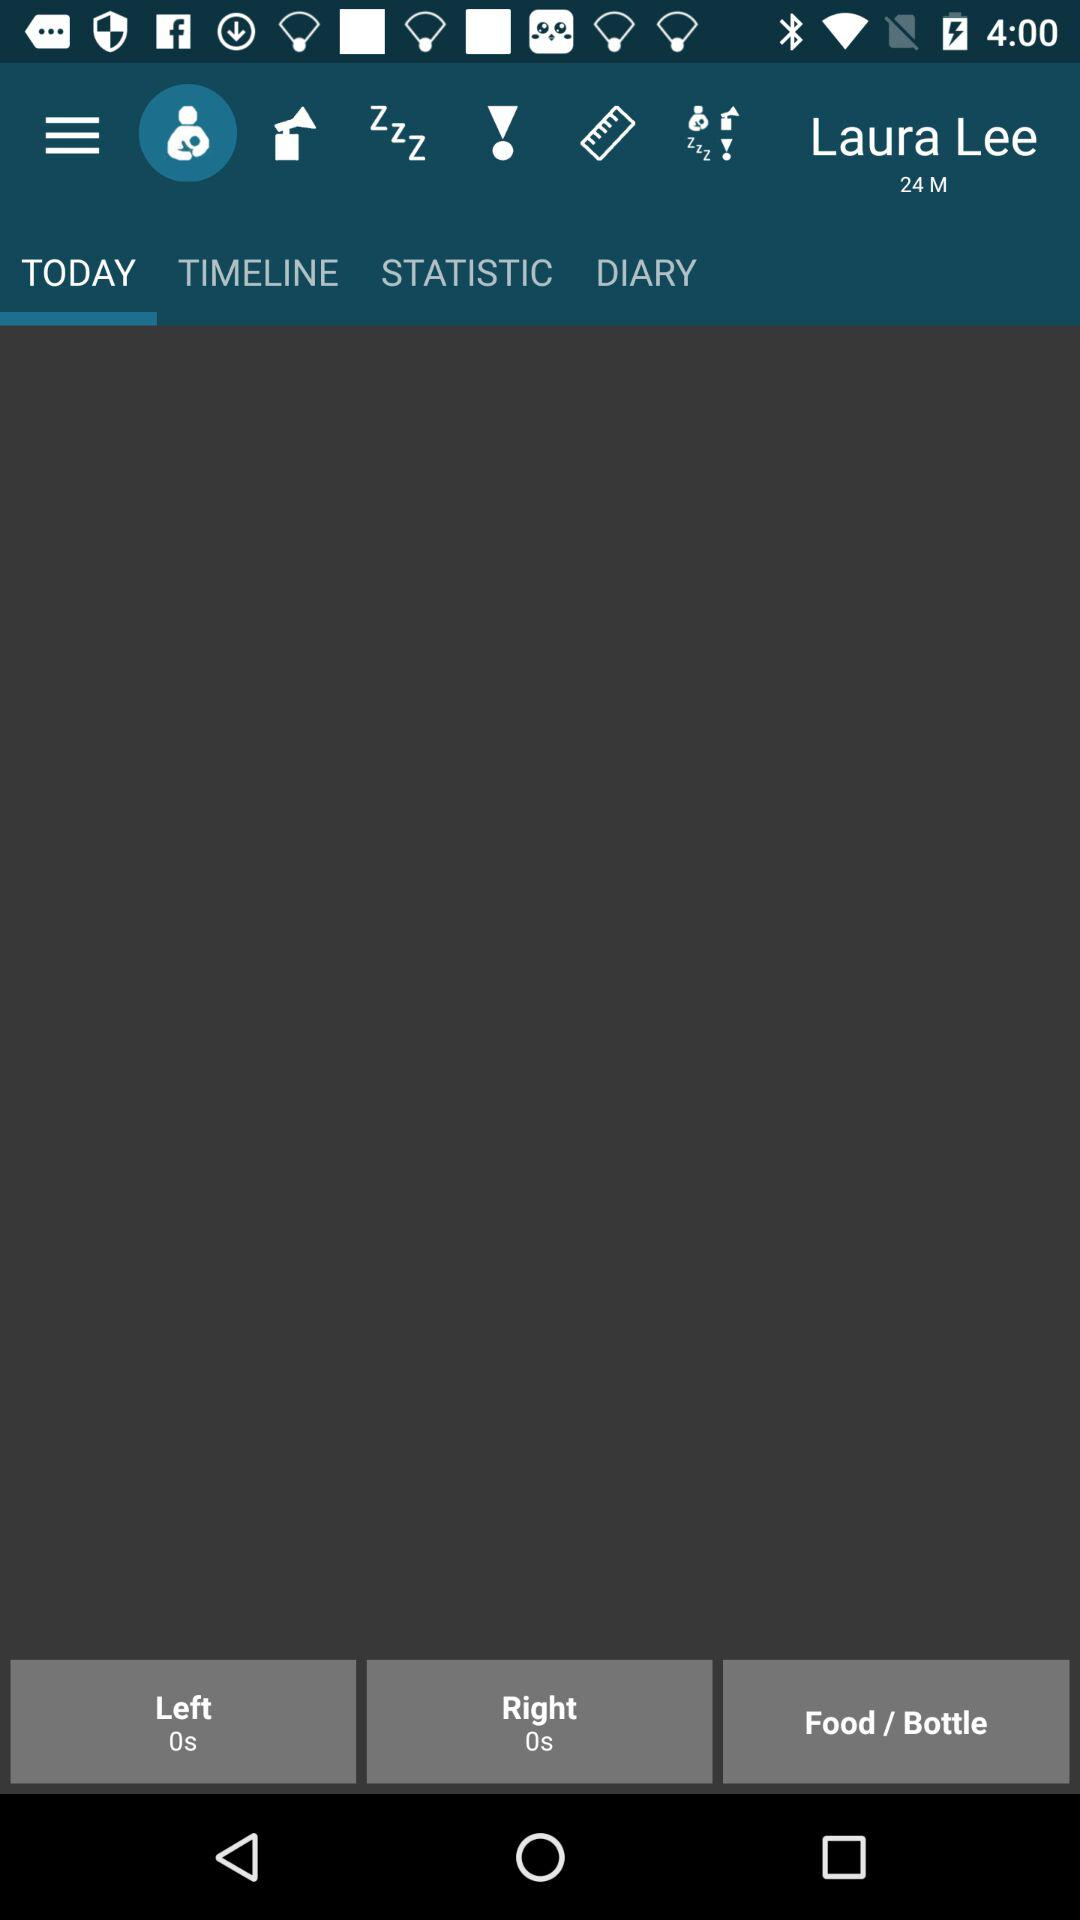Which tab is selected? The selected tab is "TODAY". 